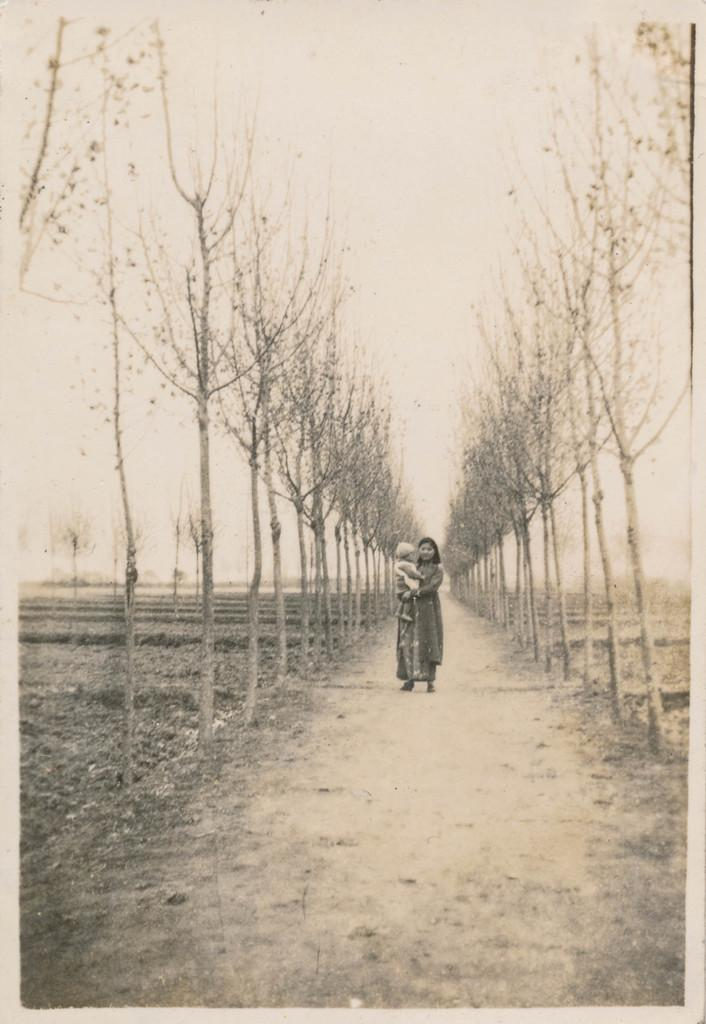Who is the main subject in the image? There is a woman in the image. What is the woman doing in the image? The woman is standing on a path and carrying a child. What can be seen in the background of the image? There are trees and the sky visible in the background of the image. What type of poison is the woman using to protect the child from spiders in the image? There is no poison or spiders present in the image. The woman is simply standing on a path and carrying a child. 